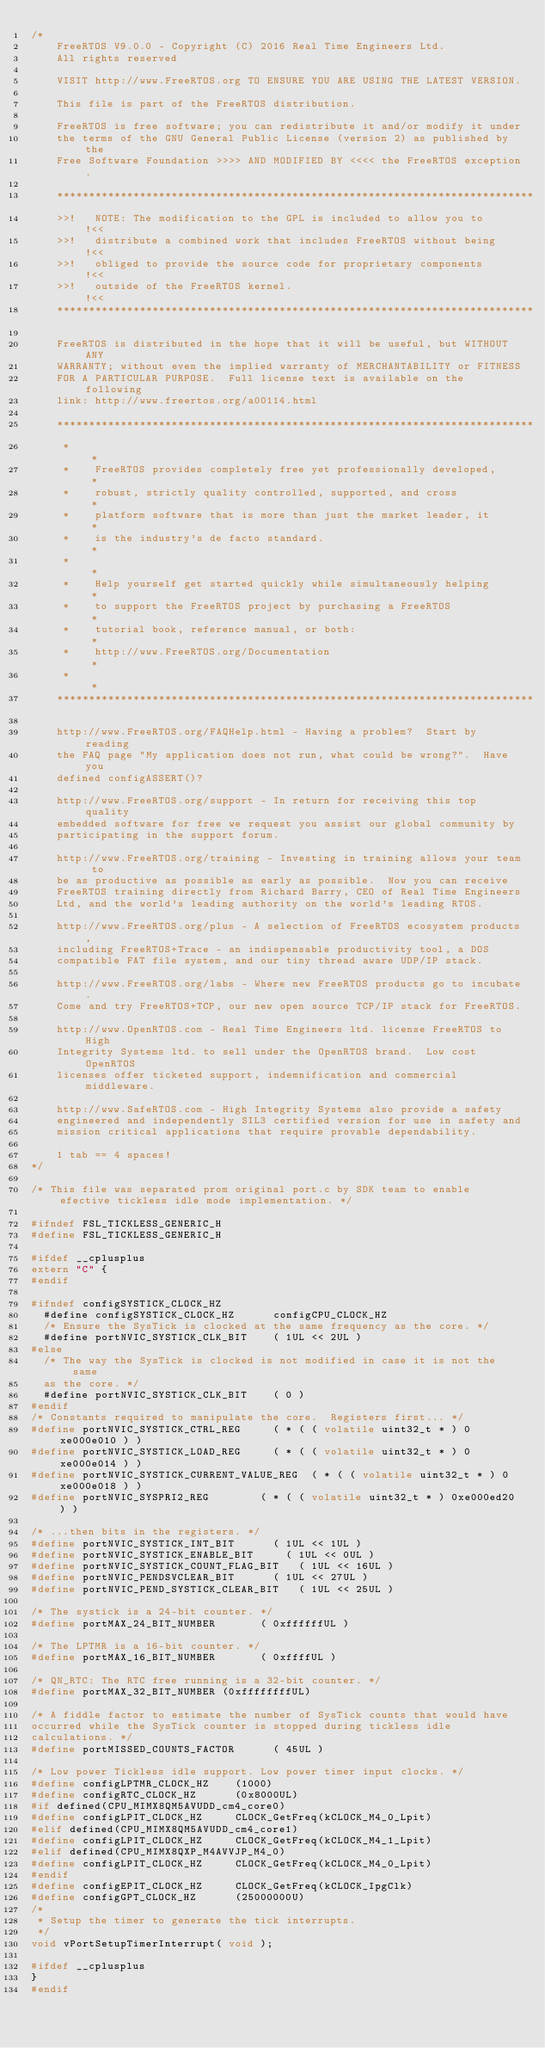<code> <loc_0><loc_0><loc_500><loc_500><_C_>/*
    FreeRTOS V9.0.0 - Copyright (C) 2016 Real Time Engineers Ltd.
    All rights reserved

    VISIT http://www.FreeRTOS.org TO ENSURE YOU ARE USING THE LATEST VERSION.

    This file is part of the FreeRTOS distribution.

    FreeRTOS is free software; you can redistribute it and/or modify it under
    the terms of the GNU General Public License (version 2) as published by the
    Free Software Foundation >>>> AND MODIFIED BY <<<< the FreeRTOS exception.

    ***************************************************************************
    >>!   NOTE: The modification to the GPL is included to allow you to     !<<
    >>!   distribute a combined work that includes FreeRTOS without being   !<<
    >>!   obliged to provide the source code for proprietary components     !<<
    >>!   outside of the FreeRTOS kernel.                                   !<<
    ***************************************************************************

    FreeRTOS is distributed in the hope that it will be useful, but WITHOUT ANY
    WARRANTY; without even the implied warranty of MERCHANTABILITY or FITNESS
    FOR A PARTICULAR PURPOSE.  Full license text is available on the following
    link: http://www.freertos.org/a00114.html

    ***************************************************************************
     *                                                                       *
     *    FreeRTOS provides completely free yet professionally developed,    *
     *    robust, strictly quality controlled, supported, and cross          *
     *    platform software that is more than just the market leader, it     *
     *    is the industry's de facto standard.                               *
     *                                                                       *
     *    Help yourself get started quickly while simultaneously helping     *
     *    to support the FreeRTOS project by purchasing a FreeRTOS           *
     *    tutorial book, reference manual, or both:                          *
     *    http://www.FreeRTOS.org/Documentation                              *
     *                                                                       *
    ***************************************************************************

    http://www.FreeRTOS.org/FAQHelp.html - Having a problem?  Start by reading
    the FAQ page "My application does not run, what could be wrong?".  Have you
    defined configASSERT()?

    http://www.FreeRTOS.org/support - In return for receiving this top quality
    embedded software for free we request you assist our global community by
    participating in the support forum.

    http://www.FreeRTOS.org/training - Investing in training allows your team to
    be as productive as possible as early as possible.  Now you can receive
    FreeRTOS training directly from Richard Barry, CEO of Real Time Engineers
    Ltd, and the world's leading authority on the world's leading RTOS.

    http://www.FreeRTOS.org/plus - A selection of FreeRTOS ecosystem products,
    including FreeRTOS+Trace - an indispensable productivity tool, a DOS
    compatible FAT file system, and our tiny thread aware UDP/IP stack.

    http://www.FreeRTOS.org/labs - Where new FreeRTOS products go to incubate.
    Come and try FreeRTOS+TCP, our new open source TCP/IP stack for FreeRTOS.

    http://www.OpenRTOS.com - Real Time Engineers ltd. license FreeRTOS to High
    Integrity Systems ltd. to sell under the OpenRTOS brand.  Low cost OpenRTOS
    licenses offer ticketed support, indemnification and commercial middleware.

    http://www.SafeRTOS.com - High Integrity Systems also provide a safety
    engineered and independently SIL3 certified version for use in safety and
    mission critical applications that require provable dependability.

    1 tab == 4 spaces!
*/

/* This file was separated prom original port.c by SDK team to enable efective tickless idle mode implementation. */

#ifndef FSL_TICKLESS_GENERIC_H
#define FSL_TICKLESS_GENERIC_H

#ifdef __cplusplus
extern "C" {
#endif

#ifndef configSYSTICK_CLOCK_HZ
	#define configSYSTICK_CLOCK_HZ			configCPU_CLOCK_HZ
	/* Ensure the SysTick is clocked at the same frequency as the core. */
	#define portNVIC_SYSTICK_CLK_BIT		( 1UL << 2UL )
#else
	/* The way the SysTick is clocked is not modified in case it is not the same
	as the core. */
	#define portNVIC_SYSTICK_CLK_BIT		( 0 )
#endif
/* Constants required to manipulate the core.  Registers first... */
#define portNVIC_SYSTICK_CTRL_REG			( * ( ( volatile uint32_t * ) 0xe000e010 ) )
#define portNVIC_SYSTICK_LOAD_REG			( * ( ( volatile uint32_t * ) 0xe000e014 ) )
#define portNVIC_SYSTICK_CURRENT_VALUE_REG	( * ( ( volatile uint32_t * ) 0xe000e018 ) )
#define portNVIC_SYSPRI2_REG				( * ( ( volatile uint32_t * ) 0xe000ed20 ) )

/* ...then bits in the registers. */
#define portNVIC_SYSTICK_INT_BIT			( 1UL << 1UL )
#define portNVIC_SYSTICK_ENABLE_BIT			( 1UL << 0UL )
#define portNVIC_SYSTICK_COUNT_FLAG_BIT		( 1UL << 16UL )
#define portNVIC_PENDSVCLEAR_BIT			( 1UL << 27UL )
#define portNVIC_PEND_SYSTICK_CLEAR_BIT		( 1UL << 25UL )

/* The systick is a 24-bit counter. */
#define portMAX_24_BIT_NUMBER				( 0xffffffUL )

/* The LPTMR is a 16-bit counter. */
#define portMAX_16_BIT_NUMBER				( 0xffffUL )

/* QN_RTC: The RTC free running is a 32-bit counter. */
#define portMAX_32_BIT_NUMBER (0xffffffffUL)

/* A fiddle factor to estimate the number of SysTick counts that would have
occurred while the SysTick counter is stopped during tickless idle
calculations. */
#define portMISSED_COUNTS_FACTOR			( 45UL )

/* Low power Tickless idle support. Low power timer input clocks. */
#define configLPTMR_CLOCK_HZ    (1000)
#define configRTC_CLOCK_HZ      (0x8000UL)
#if defined(CPU_MIMX8QM5AVUDD_cm4_core0)
#define configLPIT_CLOCK_HZ     CLOCK_GetFreq(kCLOCK_M4_0_Lpit)
#elif defined(CPU_MIMX8QM5AVUDD_cm4_core1)
#define configLPIT_CLOCK_HZ     CLOCK_GetFreq(kCLOCK_M4_1_Lpit)
#elif defined(CPU_MIMX8QXP_M4AVVJP_M4_0)
#define configLPIT_CLOCK_HZ     CLOCK_GetFreq(kCLOCK_M4_0_Lpit)
#endif
#define configEPIT_CLOCK_HZ     CLOCK_GetFreq(kCLOCK_IpgClk)
#define configGPT_CLOCK_HZ      (25000000U)
/*
 * Setup the timer to generate the tick interrupts.
 */
void vPortSetupTimerInterrupt( void );

#ifdef __cplusplus
}
#endif
</code> 